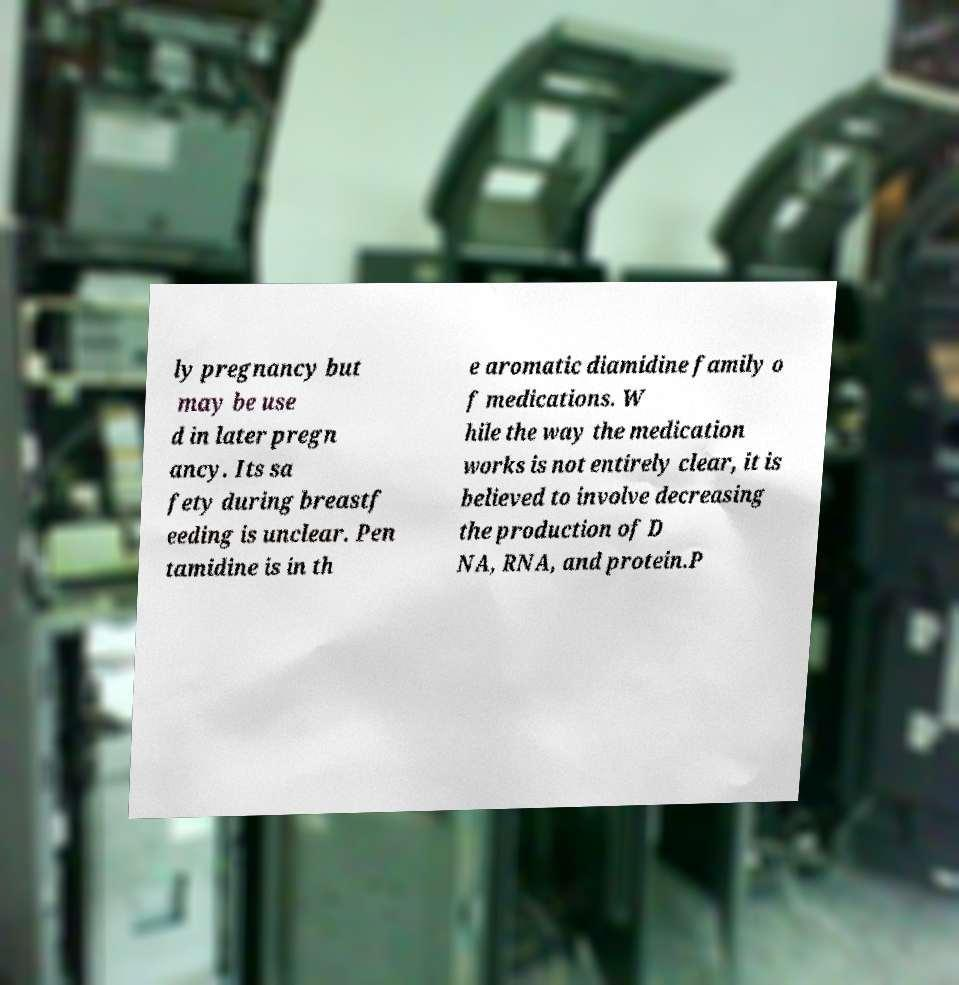For documentation purposes, I need the text within this image transcribed. Could you provide that? ly pregnancy but may be use d in later pregn ancy. Its sa fety during breastf eeding is unclear. Pen tamidine is in th e aromatic diamidine family o f medications. W hile the way the medication works is not entirely clear, it is believed to involve decreasing the production of D NA, RNA, and protein.P 